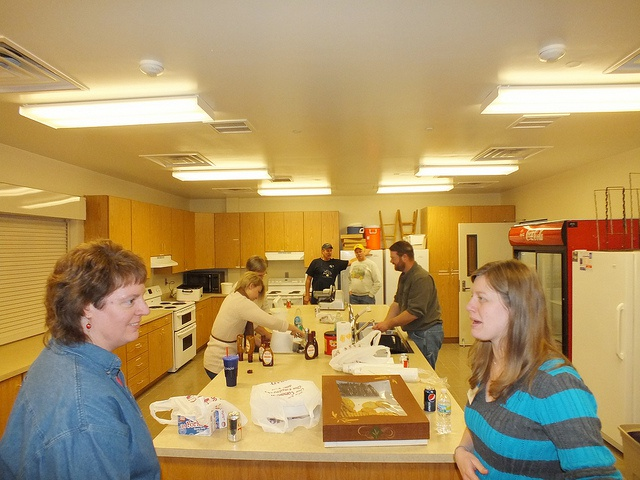Describe the objects in this image and their specific colors. I can see dining table in tan, brown, and khaki tones, people in tan, gray, lightpink, and maroon tones, people in tan, gray, lightblue, and teal tones, refrigerator in tan tones, and refrigerator in tan, brown, olive, and black tones in this image. 